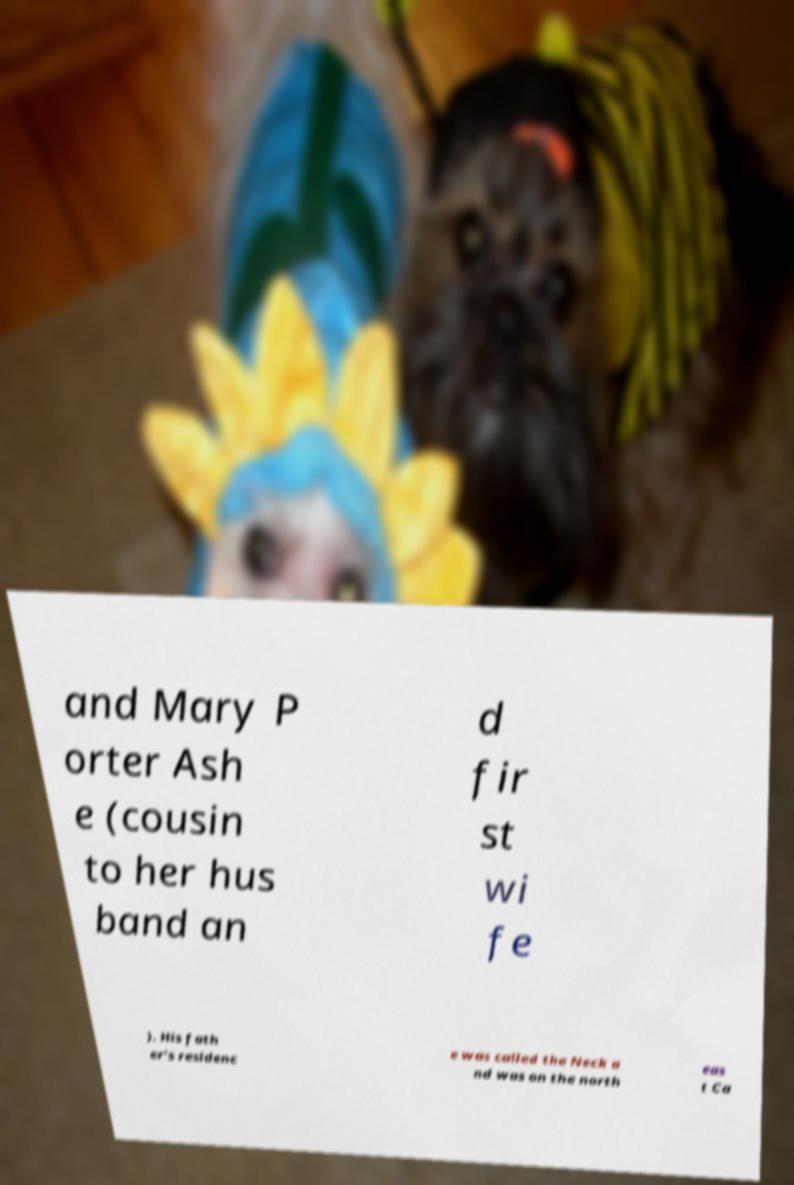Can you accurately transcribe the text from the provided image for me? and Mary P orter Ash e (cousin to her hus band an d fir st wi fe ). His fath er's residenc e was called the Neck a nd was on the north eas t Ca 